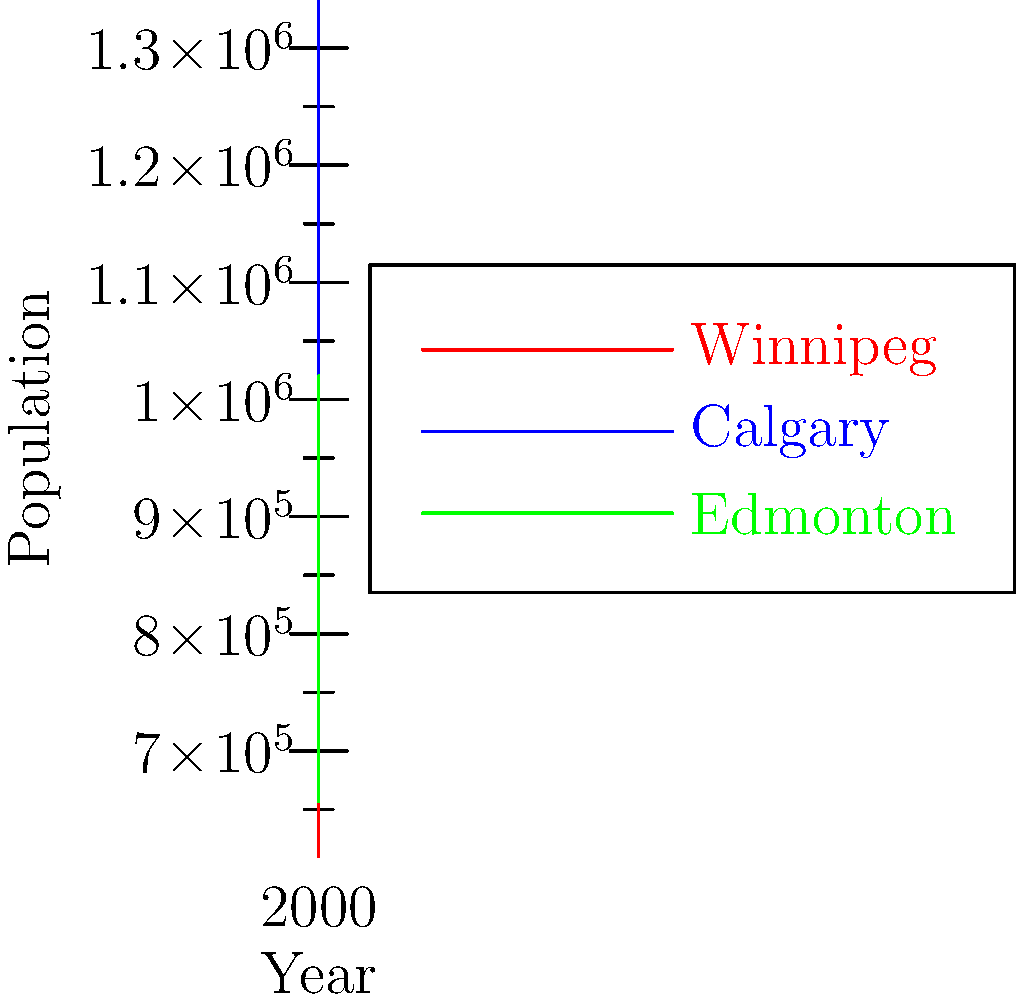Based on the line graph showing population growth from 2000 to 2020, which city had the most similar growth pattern to Winnipeg? To determine which city had the most similar growth pattern to Winnipeg, we need to analyze the slopes and shapes of the lines for each city:

1. Winnipeg (red line):
   - Shows steady, gradual growth
   - Relatively flat slope compared to others

2. Calgary (blue line):
   - Exhibits steeper growth
   - Line is consistently above Winnipeg's
   - Slope is much steeper than Winnipeg's

3. Edmonton (green line):
   - Starts closer to Winnipeg's population in 2000
   - Growth rate increases over time
   - Line shape is more curved than Winnipeg's

Comparing these patterns:
- Calgary's growth is much more rapid and linear than Winnipeg's
- Edmonton's growth, while faster than Winnipeg's, is closer in initial population and shows a more gradual increase in growth rate

Therefore, Edmonton's growth pattern is more similar to Winnipeg's than Calgary's, despite being faster overall.
Answer: Edmonton 